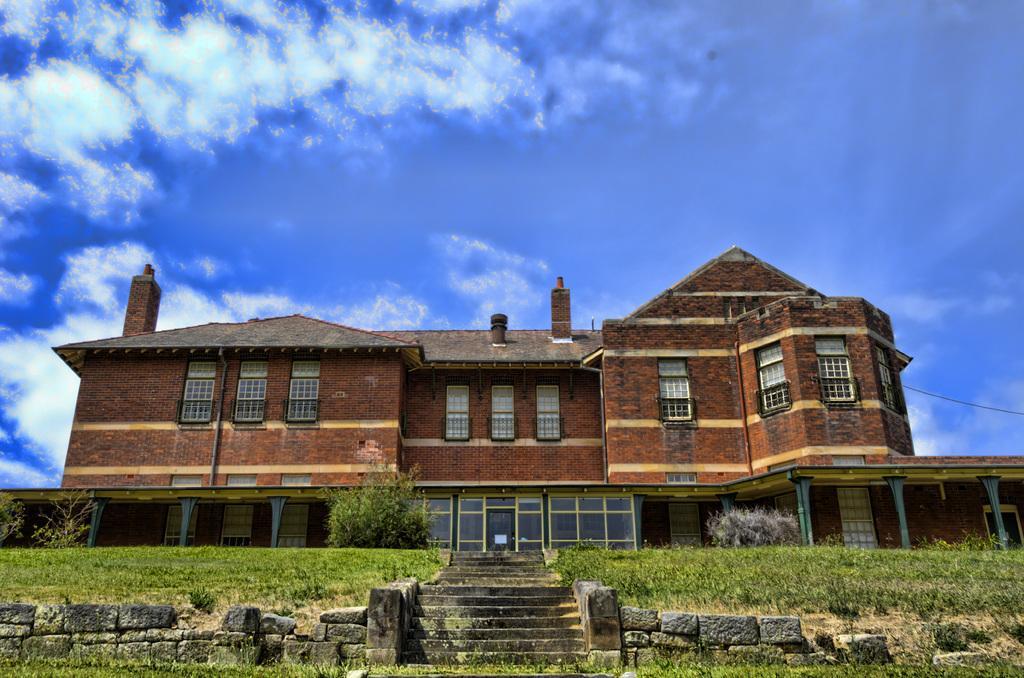In one or two sentences, can you explain what this image depicts? In this image we can see stone wall, stairs, grass, trees, brick building and sky with clouds in the background. 